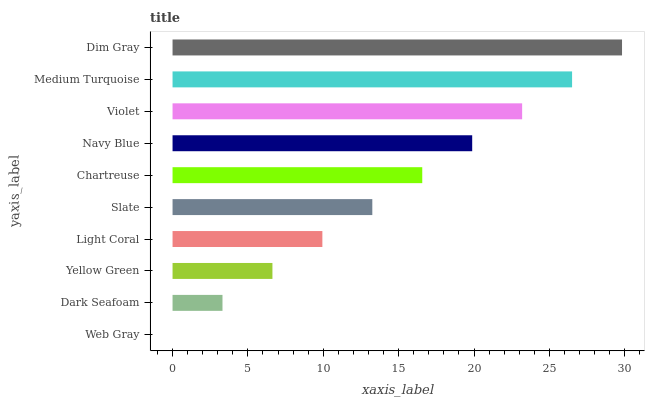Is Web Gray the minimum?
Answer yes or no. Yes. Is Dim Gray the maximum?
Answer yes or no. Yes. Is Dark Seafoam the minimum?
Answer yes or no. No. Is Dark Seafoam the maximum?
Answer yes or no. No. Is Dark Seafoam greater than Web Gray?
Answer yes or no. Yes. Is Web Gray less than Dark Seafoam?
Answer yes or no. Yes. Is Web Gray greater than Dark Seafoam?
Answer yes or no. No. Is Dark Seafoam less than Web Gray?
Answer yes or no. No. Is Chartreuse the high median?
Answer yes or no. Yes. Is Slate the low median?
Answer yes or no. Yes. Is Dim Gray the high median?
Answer yes or no. No. Is Web Gray the low median?
Answer yes or no. No. 